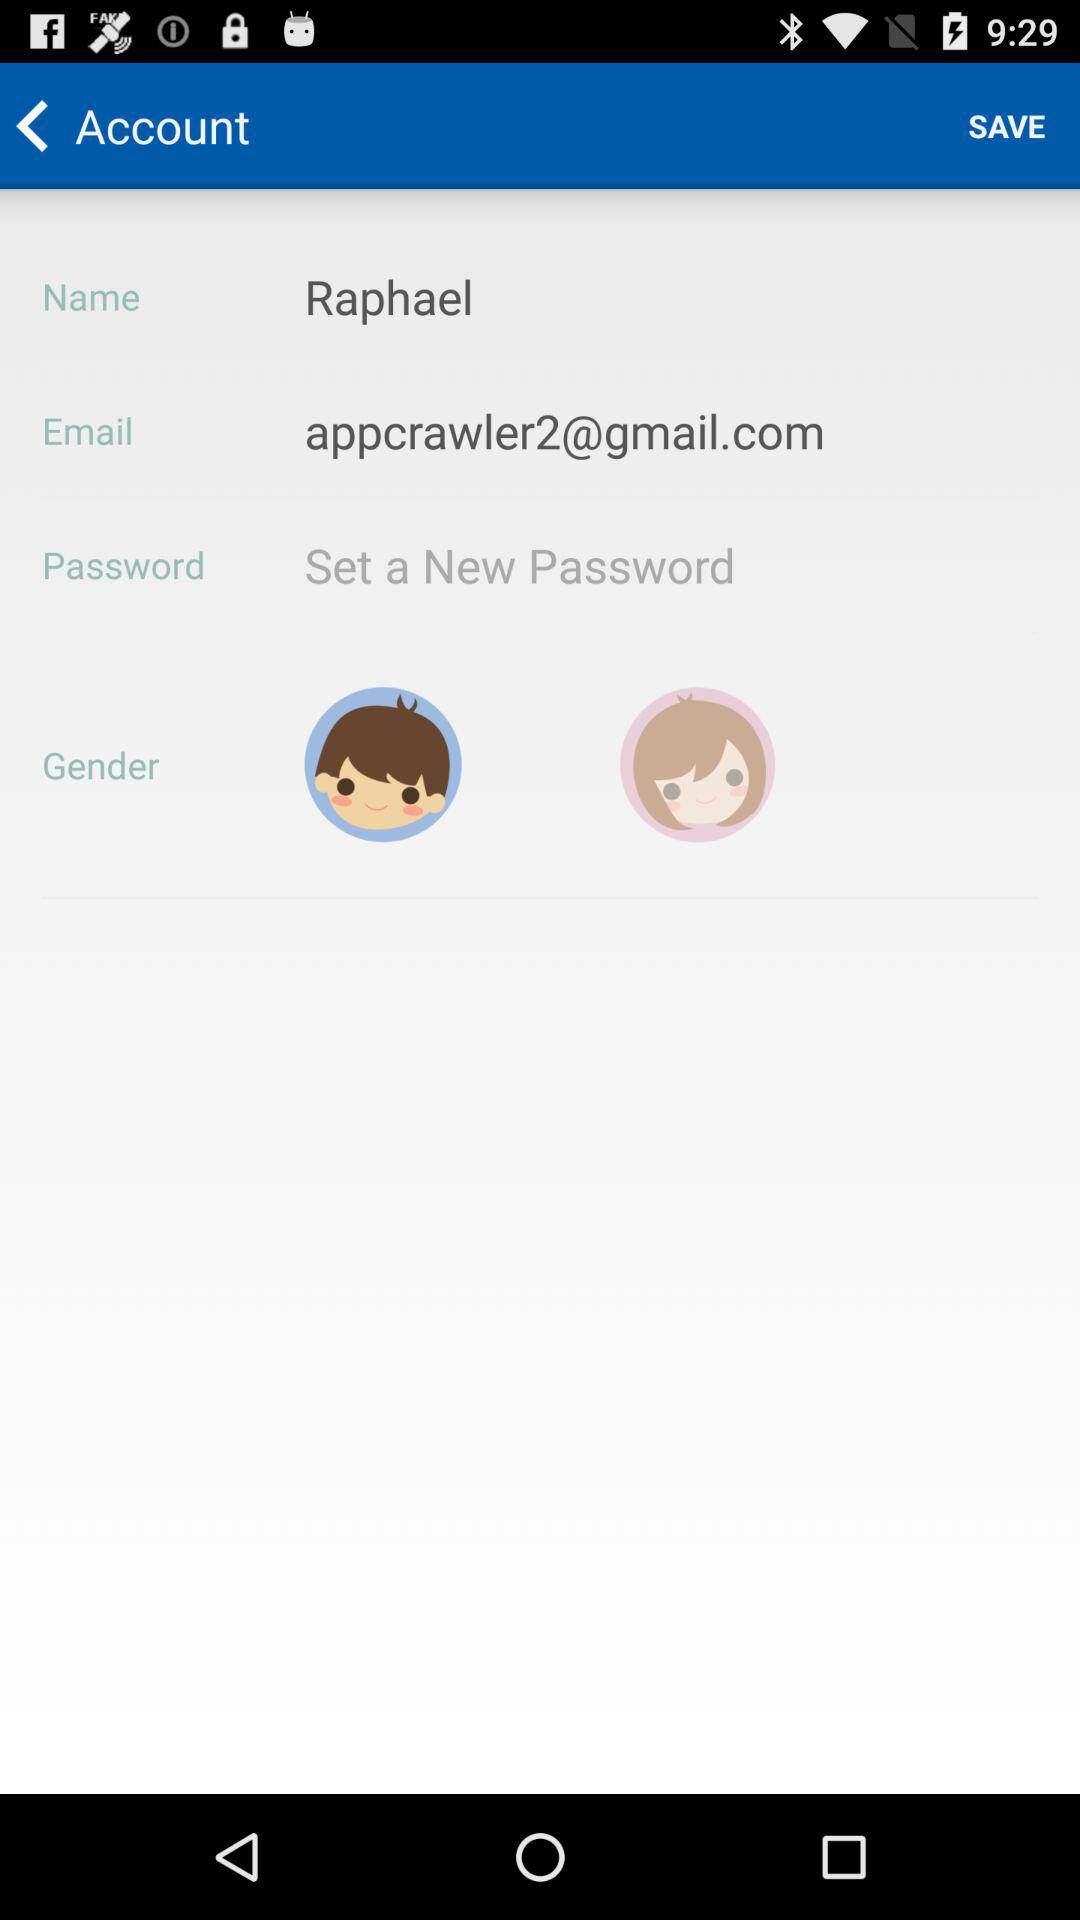What's the email address? The email address is appcrawler2@gmail.com. 